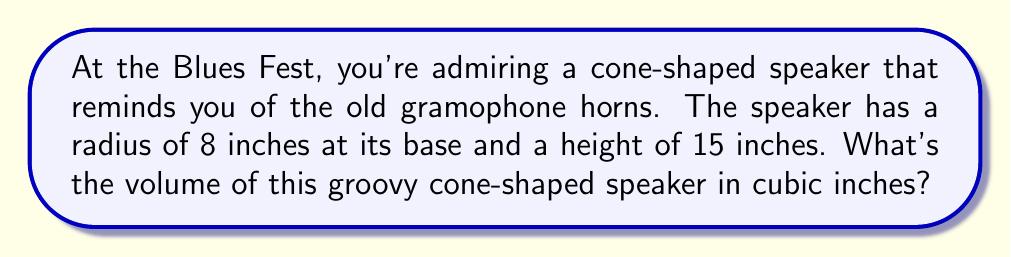What is the answer to this math problem? Let's break this down step-by-step:

1) The formula for the volume of a cone is:

   $$V = \frac{1}{3}\pi r^2 h$$

   Where $r$ is the radius of the base and $h$ is the height of the cone.

2) We're given:
   - Radius ($r$) = 8 inches
   - Height ($h$) = 15 inches

3) Let's substitute these values into our formula:

   $$V = \frac{1}{3}\pi (8^2)(15)$$

4) Let's simplify inside the parentheses:

   $$V = \frac{1}{3}\pi (64)(15)$$

5) Multiply:

   $$V = \frac{1}{3}\pi (960)$$

6) Simplify:

   $$V = 320\pi$$

7) If we want to calculate this to a decimal place:

   $$V \approx 1005.31 \text{ cubic inches}$$

Thus, the volume of the cone-shaped speaker is $320\pi$ or approximately 1005.31 cubic inches.
Answer: $320\pi$ cubic inches 